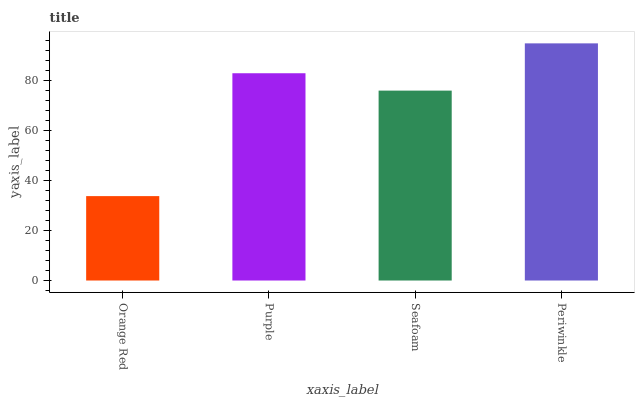Is Purple the minimum?
Answer yes or no. No. Is Purple the maximum?
Answer yes or no. No. Is Purple greater than Orange Red?
Answer yes or no. Yes. Is Orange Red less than Purple?
Answer yes or no. Yes. Is Orange Red greater than Purple?
Answer yes or no. No. Is Purple less than Orange Red?
Answer yes or no. No. Is Purple the high median?
Answer yes or no. Yes. Is Seafoam the low median?
Answer yes or no. Yes. Is Seafoam the high median?
Answer yes or no. No. Is Purple the low median?
Answer yes or no. No. 